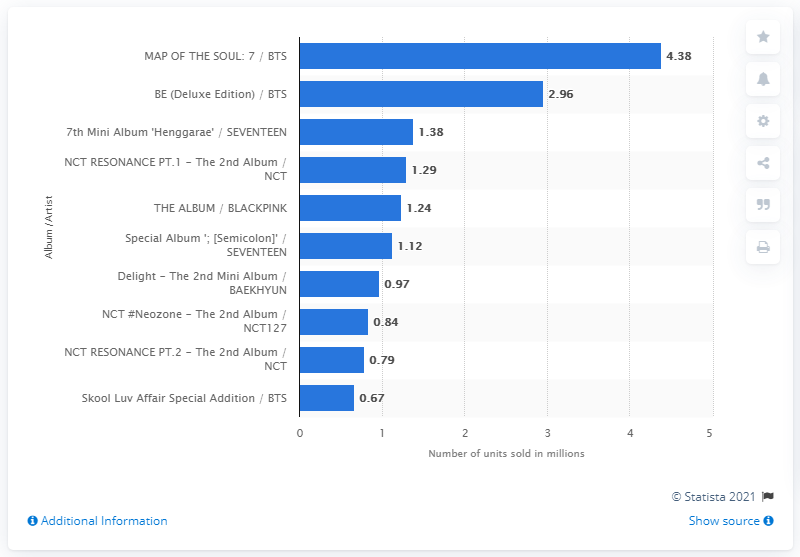Draw attention to some important aspects in this diagram. According to sales data from South Korea in 2020, a total of 4,380 copies of MAP OF THE SOUL: 7 were sold. In 2020, a total of 4,380 copies of "MAP OF THE SOUL: 7" were sold in South Korea. 